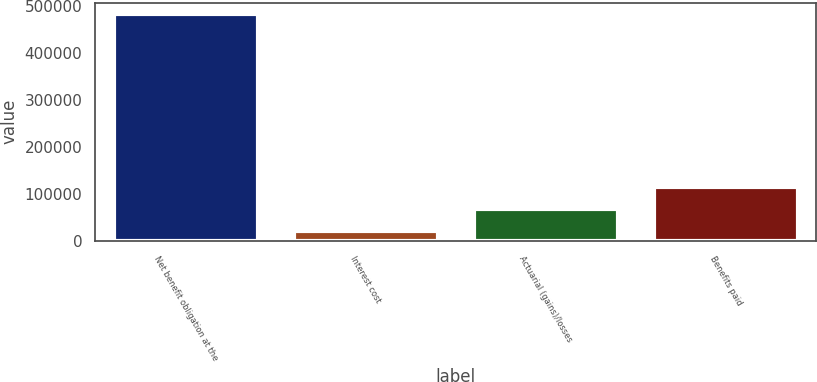Convert chart. <chart><loc_0><loc_0><loc_500><loc_500><bar_chart><fcel>Net benefit obligation at the<fcel>Interest cost<fcel>Actuarial (gains)/losses<fcel>Benefits paid<nl><fcel>482542<fcel>21377<fcel>67493.5<fcel>113610<nl></chart> 